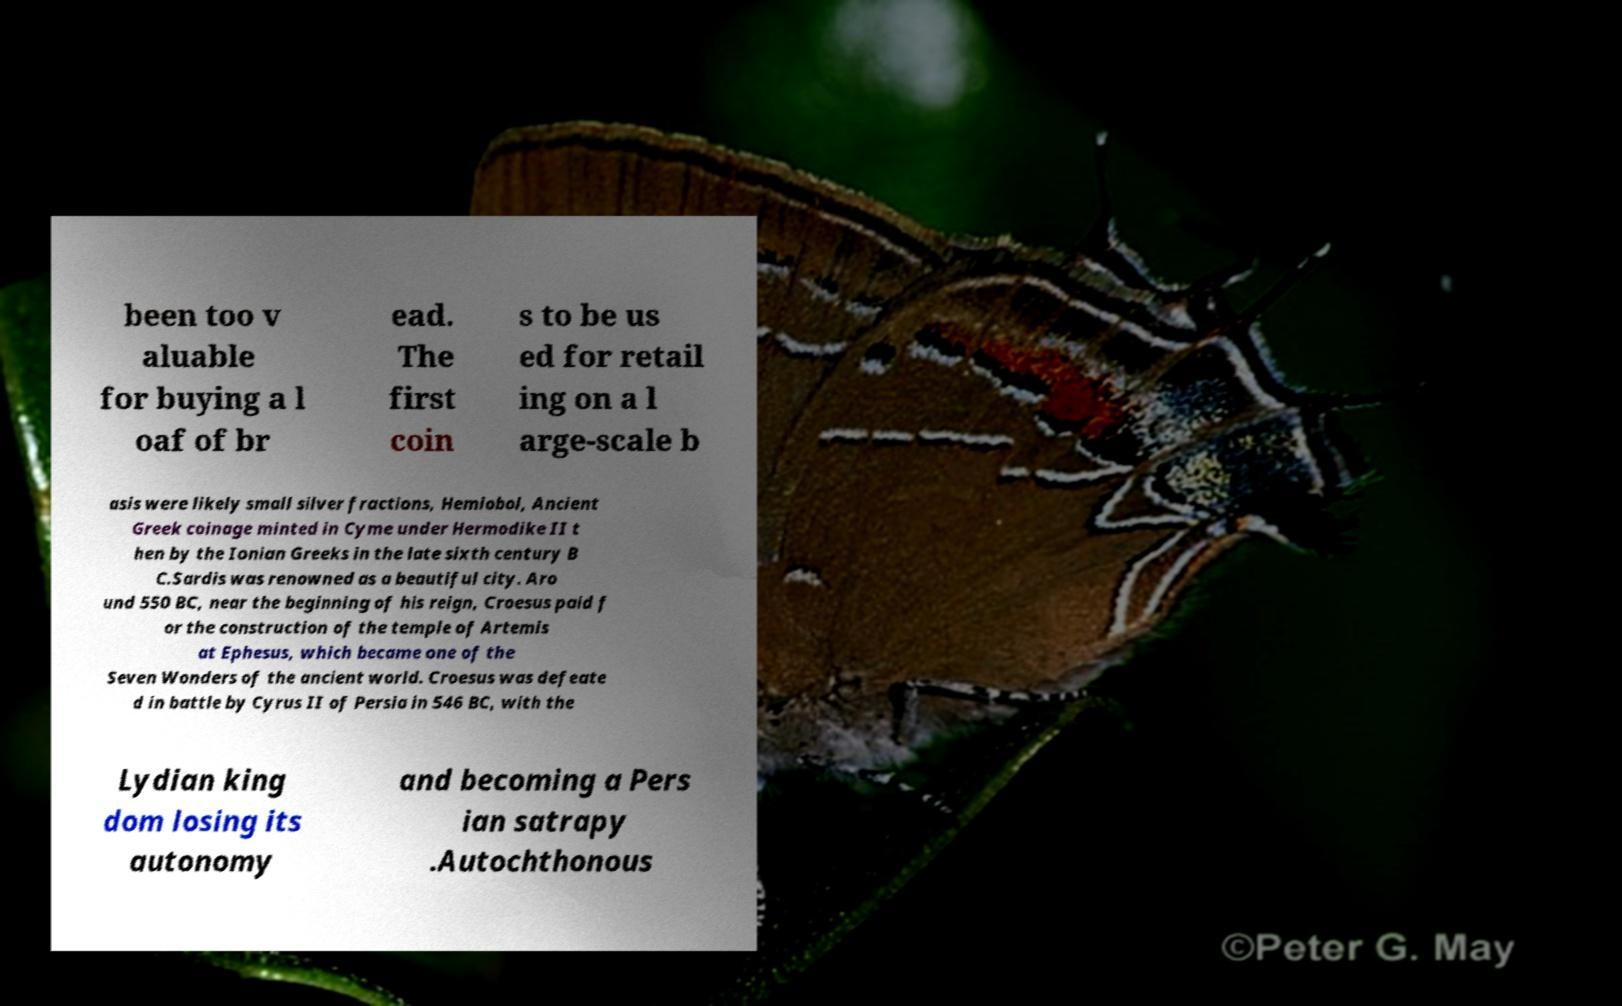What messages or text are displayed in this image? I need them in a readable, typed format. been too v aluable for buying a l oaf of br ead. The first coin s to be us ed for retail ing on a l arge-scale b asis were likely small silver fractions, Hemiobol, Ancient Greek coinage minted in Cyme under Hermodike II t hen by the Ionian Greeks in the late sixth century B C.Sardis was renowned as a beautiful city. Aro und 550 BC, near the beginning of his reign, Croesus paid f or the construction of the temple of Artemis at Ephesus, which became one of the Seven Wonders of the ancient world. Croesus was defeate d in battle by Cyrus II of Persia in 546 BC, with the Lydian king dom losing its autonomy and becoming a Pers ian satrapy .Autochthonous 